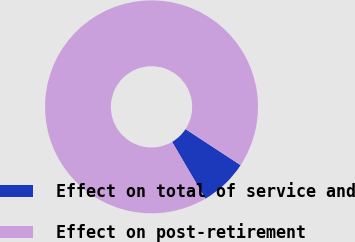Convert chart. <chart><loc_0><loc_0><loc_500><loc_500><pie_chart><fcel>Effect on total of service and<fcel>Effect on post-retirement<nl><fcel>7.34%<fcel>92.66%<nl></chart> 